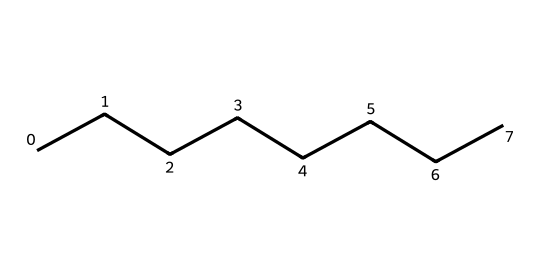How many carbon atoms are present in this hydrocarbon? The SMILES representation shows a linear arrangement of carbon atoms labeled as "C". Counting the number of carbon atoms in "CCCCCCCC" gives us a total of 8 carbon atoms.
Answer: 8 What is the common name for this hydrocarbon? The linear carbon chain with 8 carbons is commonly known as octane.
Answer: octane How many hydrogen atoms are present in octane? Each carbon in a saturated hydrocarbon is typically bonded to enough hydrogen atoms to make four total connections. For octane, with 8 carbon atoms (C8), the formula is CnH(2n+2), where n = 8. Thus, there are 18 hydrogen atoms (2*8 + 2 = 18).
Answer: 18 Is octane a saturated or unsaturated hydrocarbon? Octane has only single bonds between carbon atoms and is fully saturated with hydrogen, indicating it is a saturated hydrocarbon.
Answer: saturated What kind of structural arrangement does octane have? The SMILES representation "CCCCCCCC" indicates a straight-chain or linear structure, as all carbon atoms are connected in a single line without branching.
Answer: linear How would you classify octane in terms of its bonding? Since octane contains only single bonds (C-C) throughout its structure, it can be classified as an alkane, which is a type of saturated hydrocarbon.
Answer: alkane 